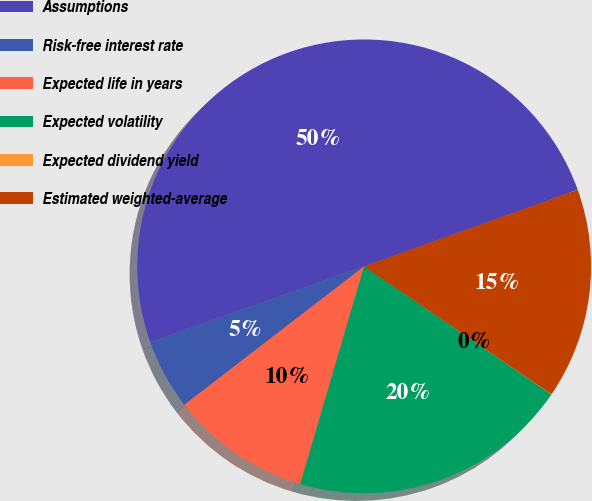Convert chart to OTSL. <chart><loc_0><loc_0><loc_500><loc_500><pie_chart><fcel>Assumptions<fcel>Risk-free interest rate<fcel>Expected life in years<fcel>Expected volatility<fcel>Expected dividend yield<fcel>Estimated weighted-average<nl><fcel>49.93%<fcel>5.02%<fcel>10.01%<fcel>19.99%<fcel>0.03%<fcel>15.0%<nl></chart> 